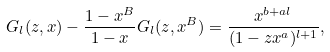Convert formula to latex. <formula><loc_0><loc_0><loc_500><loc_500>G _ { l } ( z , x ) - \frac { 1 - x ^ { B } } { 1 - x } G _ { l } ( z , x ^ { B } ) = \frac { x ^ { b + a l } } { ( 1 - z x ^ { a } ) ^ { l + 1 } } ,</formula> 